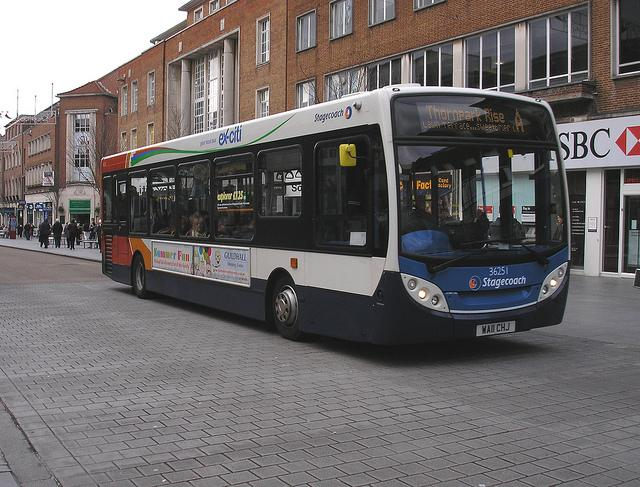What type street does this bus drive on?

Choices:
A) brick
B) concrete
C) tar
D) dirt brick 